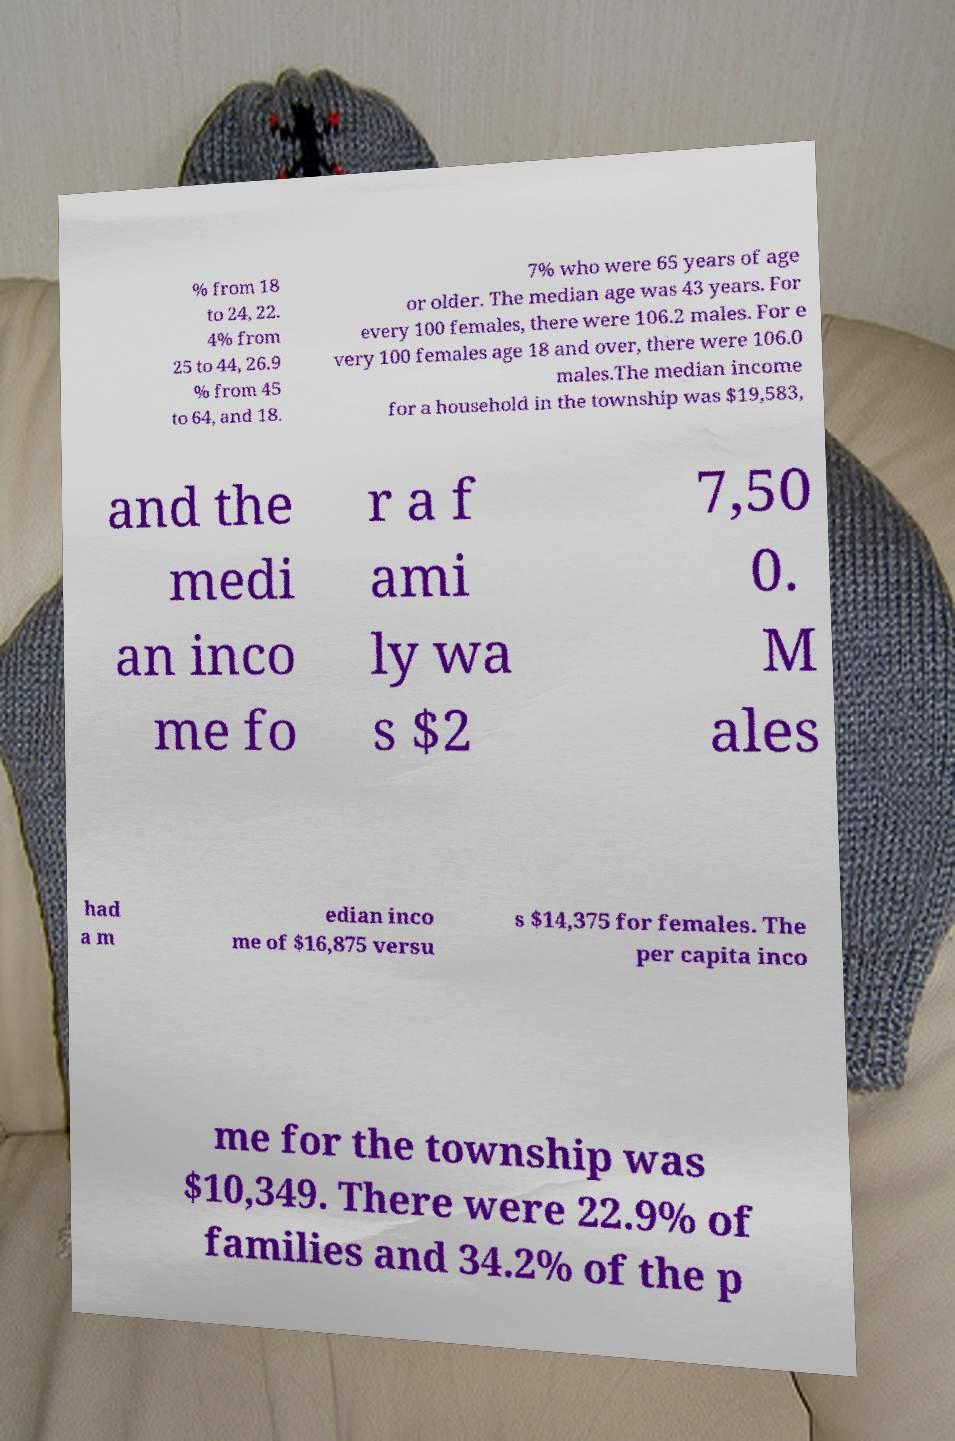I need the written content from this picture converted into text. Can you do that? % from 18 to 24, 22. 4% from 25 to 44, 26.9 % from 45 to 64, and 18. 7% who were 65 years of age or older. The median age was 43 years. For every 100 females, there were 106.2 males. For e very 100 females age 18 and over, there were 106.0 males.The median income for a household in the township was $19,583, and the medi an inco me fo r a f ami ly wa s $2 7,50 0. M ales had a m edian inco me of $16,875 versu s $14,375 for females. The per capita inco me for the township was $10,349. There were 22.9% of families and 34.2% of the p 